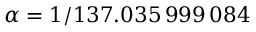<formula> <loc_0><loc_0><loc_500><loc_500>\alpha = 1 / 1 3 7 . 0 3 5 \, 9 9 9 \, 0 8 4</formula> 